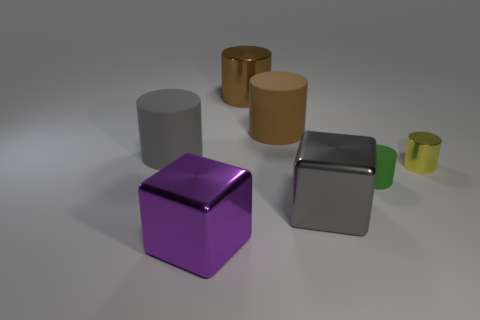Subtract all blue cylinders. Subtract all yellow cubes. How many cylinders are left? 5 Add 3 large gray shiny objects. How many objects exist? 10 Subtract all cylinders. How many objects are left? 2 Subtract all small green objects. Subtract all brown shiny things. How many objects are left? 5 Add 4 large brown matte objects. How many large brown matte objects are left? 5 Add 4 cubes. How many cubes exist? 6 Subtract 1 yellow cylinders. How many objects are left? 6 